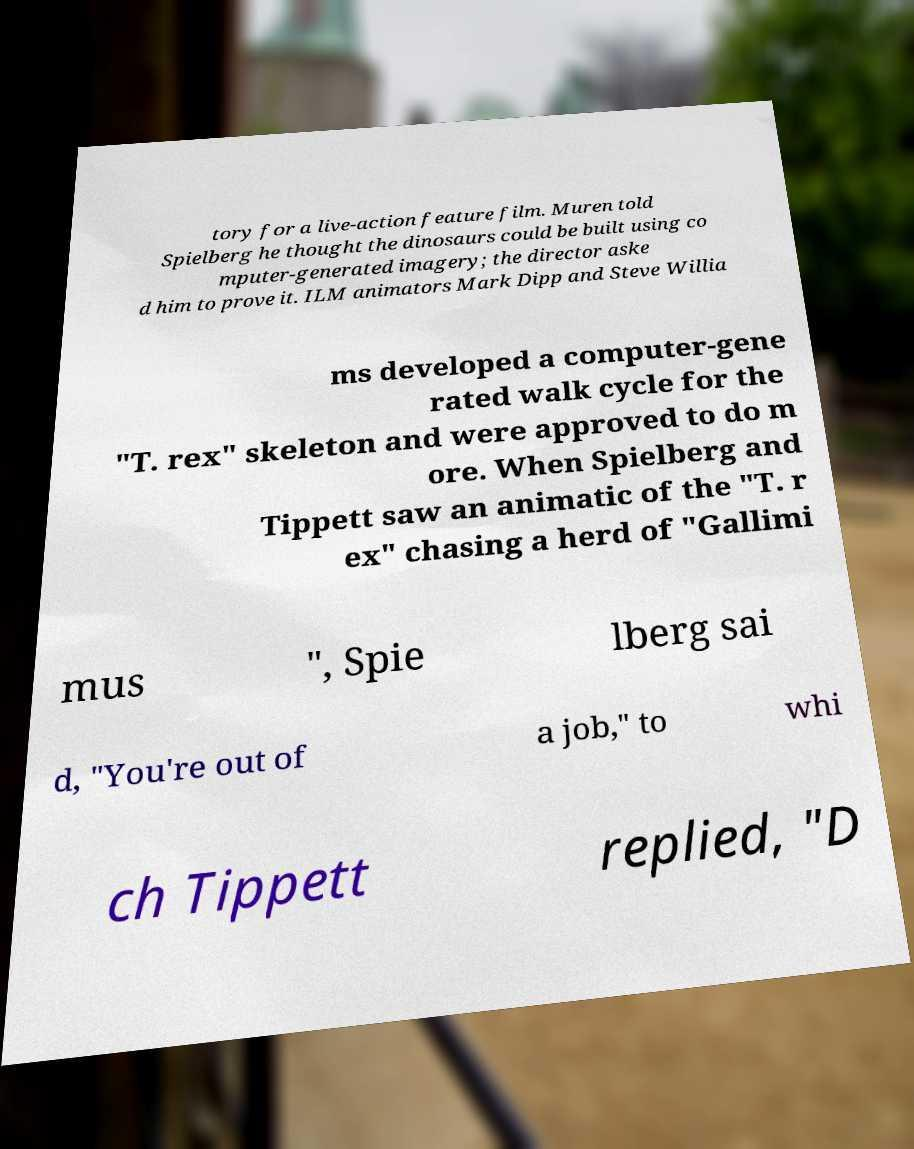Can you accurately transcribe the text from the provided image for me? tory for a live-action feature film. Muren told Spielberg he thought the dinosaurs could be built using co mputer-generated imagery; the director aske d him to prove it. ILM animators Mark Dipp and Steve Willia ms developed a computer-gene rated walk cycle for the "T. rex" skeleton and were approved to do m ore. When Spielberg and Tippett saw an animatic of the "T. r ex" chasing a herd of "Gallimi mus ", Spie lberg sai d, "You're out of a job," to whi ch Tippett replied, "D 